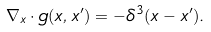Convert formula to latex. <formula><loc_0><loc_0><loc_500><loc_500>\nabla _ { x } \cdot { g } ( { x } , { x } ^ { \prime } ) = - \delta ^ { 3 } ( { x } - { x } ^ { \prime } ) .</formula> 